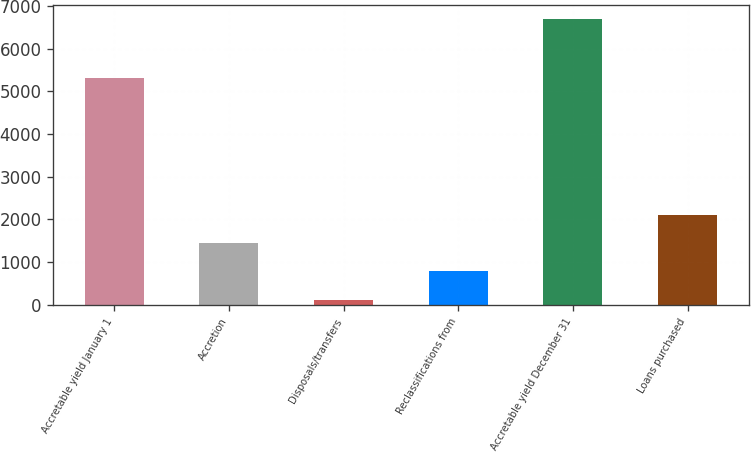Convert chart. <chart><loc_0><loc_0><loc_500><loc_500><bar_chart><fcel>Accretable yield January 1<fcel>Accretion<fcel>Disposals/transfers<fcel>Reclassifications from<fcel>Accretable yield December 31<fcel>Loans purchased<nl><fcel>5302.5<fcel>1455.5<fcel>109<fcel>797<fcel>6694<fcel>2114<nl></chart> 